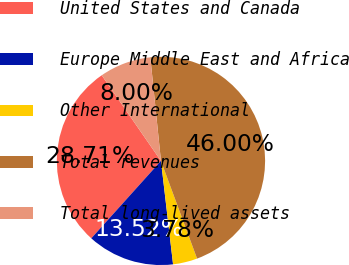Convert chart to OTSL. <chart><loc_0><loc_0><loc_500><loc_500><pie_chart><fcel>United States and Canada<fcel>Europe Middle East and Africa<fcel>Other International<fcel>Total revenues<fcel>Total long-lived assets<nl><fcel>28.71%<fcel>13.52%<fcel>3.78%<fcel>46.0%<fcel>8.0%<nl></chart> 